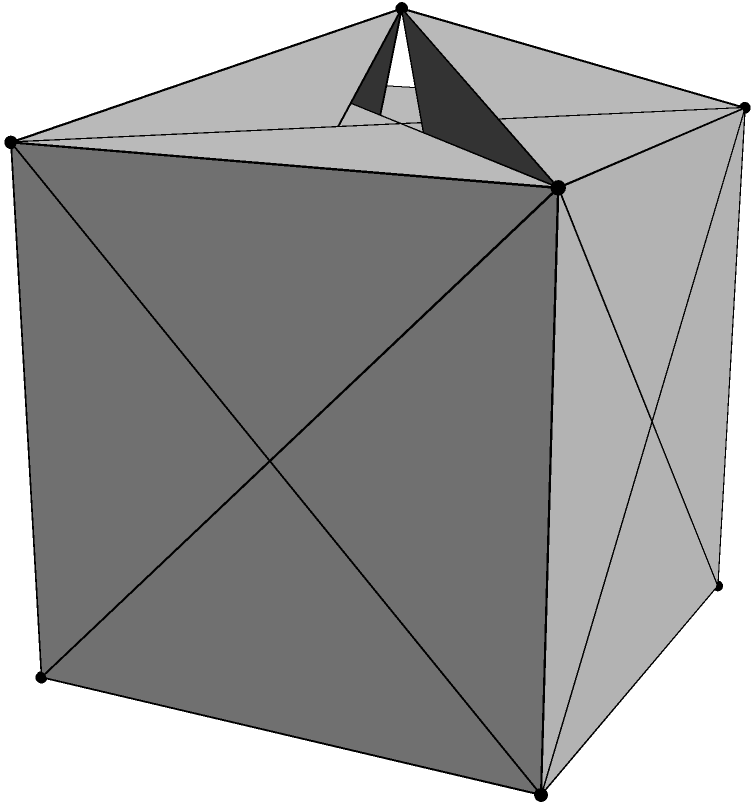In the spirit of inclusive education, consider the polyhedron shown above, which is formed by combining a cube with two square pyramids attached to opposite faces. How many faces, edges, and vertices does this complex solid have? Express your answer as an ordered triple $(F, E, V)$, where $F$ is the number of faces, $E$ is the number of edges, and $V$ is the number of vertices. Let's approach this step-by-step:

1. First, let's count the faces:
   - The cube has 6 faces
   - We removed 2 faces to attach the pyramids
   - Each pyramid adds 4 triangular faces
   So, the total number of faces is: $6 - 2 + 4 + 4 = 12$ faces

2. Now, let's count the edges:
   - The cube has 12 edges
   - Each pyramid adds 4 new edges
   So, the total number of edges is: $12 + 4 + 4 = 20$ edges

3. Finally, let's count the vertices:
   - The cube has 8 vertices
   - Each pyramid adds 1 new vertex (its apex)
   So, the total number of vertices is: $8 + 1 + 1 = 10$ vertices

4. We can verify our count using Euler's formula for polyhedra:
   $V - E + F = 2$
   Substituting our values: $10 - 20 + 12 = 2$
   This confirms that our count is correct.

Therefore, the polyhedron has 12 faces, 20 edges, and 10 vertices.
Answer: $(12, 20, 10)$ 